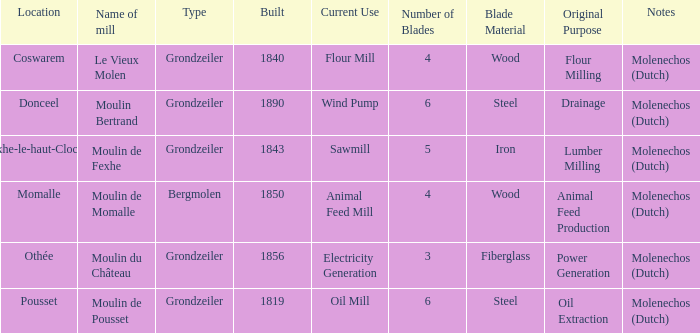Could you help me parse every detail presented in this table? {'header': ['Location', 'Name of mill', 'Type', 'Built', 'Current Use', 'Number of Blades', 'Blade Material', 'Original Purpose', 'Notes'], 'rows': [['Coswarem', 'Le Vieux Molen', 'Grondzeiler', '1840', 'Flour Mill', '4', 'Wood', 'Flour Milling', 'Molenechos (Dutch)'], ['Donceel', 'Moulin Bertrand', 'Grondzeiler', '1890', 'Wind Pump', '6', 'Steel', 'Drainage', 'Molenechos (Dutch)'], ['Fexhe-le-haut-Clocher', 'Moulin de Fexhe', 'Grondzeiler', '1843', 'Sawmill', '5', 'Iron', 'Lumber Milling', 'Molenechos (Dutch)'], ['Momalle', 'Moulin de Momalle', 'Bergmolen', '1850', 'Animal Feed Mill', '4', 'Wood', 'Animal Feed Production', 'Molenechos (Dutch)'], ['Othée', 'Moulin du Château', 'Grondzeiler', '1856', 'Electricity Generation', '3', 'Fiberglass', 'Power Generation', 'Molenechos (Dutch)'], ['Pousset', 'Moulin de Pousset', 'Grondzeiler', '1819', 'Oil Mill', '6', 'Steel', 'Oil Extraction', 'Molenechos (Dutch)']]} What is year Built of the Moulin de Momalle Mill? 1850.0. 